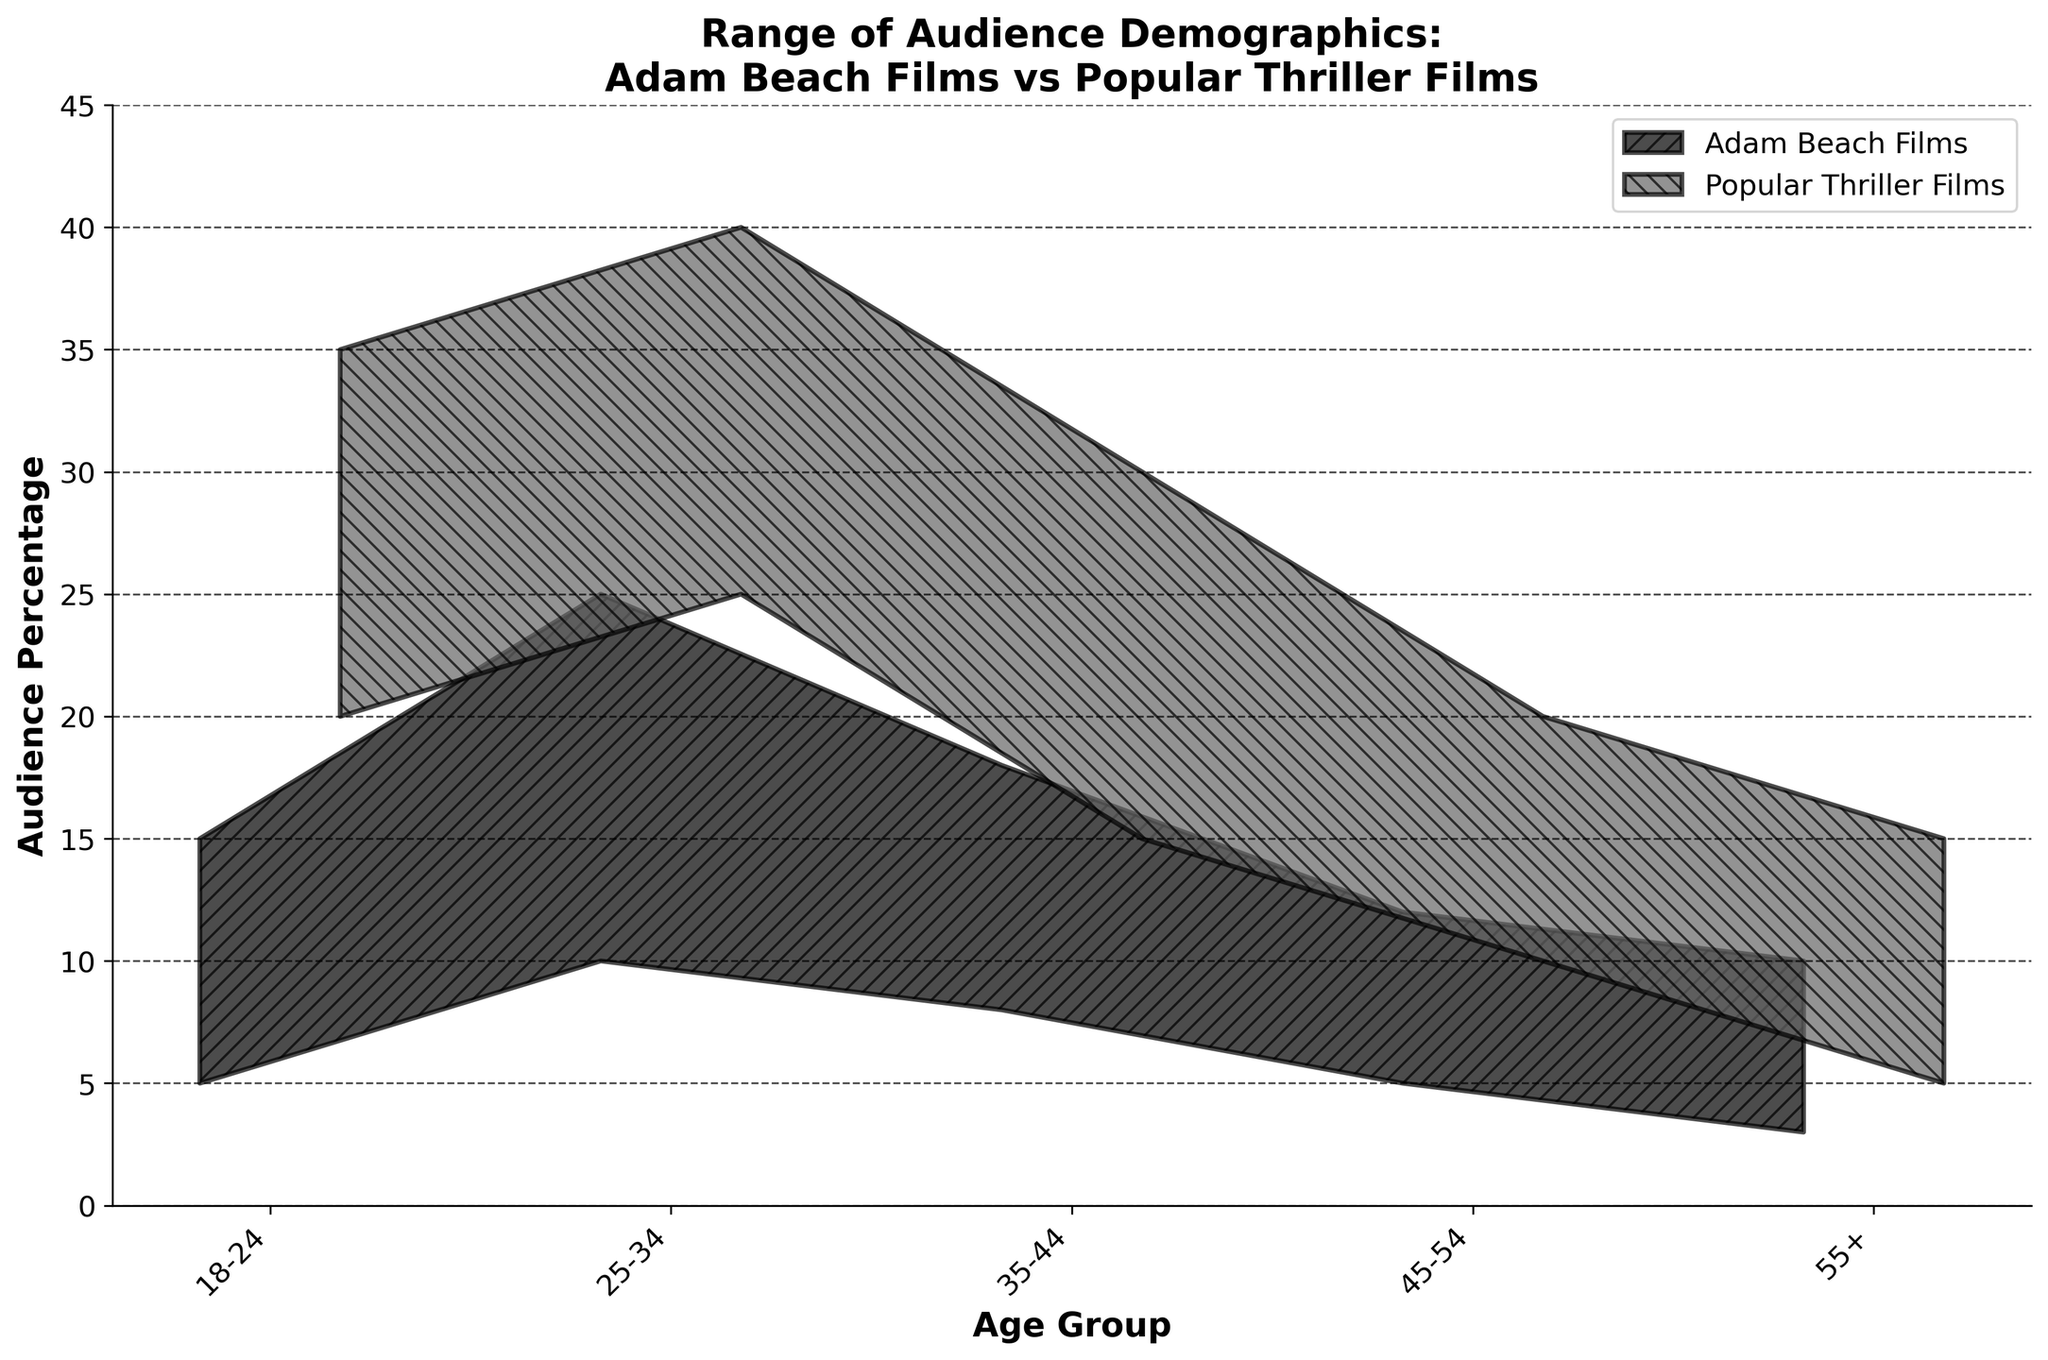what is the range of audience percentage for the age group 18-24 in Adam Beach Films? To find the range of audience percentage for the age group 18-24 in Adam Beach Films, you need to identify the lower and upper bounds for this age group in the Adam Beach Films category. The lower bound is 5%, and the upper bound is 15%.
Answer: 5-15% which age group has the widest range of audience percentage in Popular Thriller Films? Examine the age groups in the Popular Thriller Films category and calculate the range for each one by subtracting the lower bound from the upper bound. The largest range will indicate the widest audience percentage. For the age group 25-34, the range is 40-25=15, which is the widest.
Answer: 25-34 are there any age groups where Adam Beach Films' upper bound is less than Popular Thriller Films' lower bound? To answer this, compare the upper bound of each age group for Adam Beach Films to the lower bound of the corresponding age group for Popular Thriller Films. For the age group 18-24, Adam Beach Films' upper bound is 15, whereas Popular Thriller Films' lower bound is 20, which fits the criteria.
Answer: Yes, 18-24 what is the average upper bound percentage for all age groups in Adam Beach Films? To find the average upper bound for Adam Beach Films across all age groups, sum the upper bound values and divide by the number of age groups. The calculation is (15 + 25 + 18 + 12 + 10) / 5 = 80 / 5 = 16%.
Answer: 16% which age group shows the greatest similarity in range between Adam Beach Films and Popular Thriller Films? To determine which age group has the most similar range between the two film categories, compare the lower and upper bounds directly. The age group 55+ has a range of 3-10 for Adam Beach Films and 5-15 for Popular Thriller Films, which makes them the most similar.
Answer: 55+ Beyond comparing individual ranges, what general trend can you observe about the audience demographics for Adam Beach Films compared to Popular Thriller Films? By analyzing the overall ranges for all age groups, one can observe that Adam Beach Films generally have a lower audience percentage across all age groups compared to Popular Thriller Films, especially among younger audiences.
Answer: Adam Beach Films have generally lower audience percentages across all age groups which age group has the smallest disparity between the upper bounds of Adam Beach Films and Popular Thriller Films? To find the age group with the smallest disparity between upper bounds, subtract the upper bound of Adam Beach Films from the upper bound of Popular Thriller Films for each age group. The age group 55+ has the smallest difference: 15 - 10 = 5.
Answer: 55+ is there any age group where the range is the same for both Adam Beach Films and Popular Thriller Films? To answer this, compare the range (upper bound - lower bound) for each age group in both film categories. All the ranges differ between the two categories for each age group, so there is no age group with the same range for both.
Answer: No 